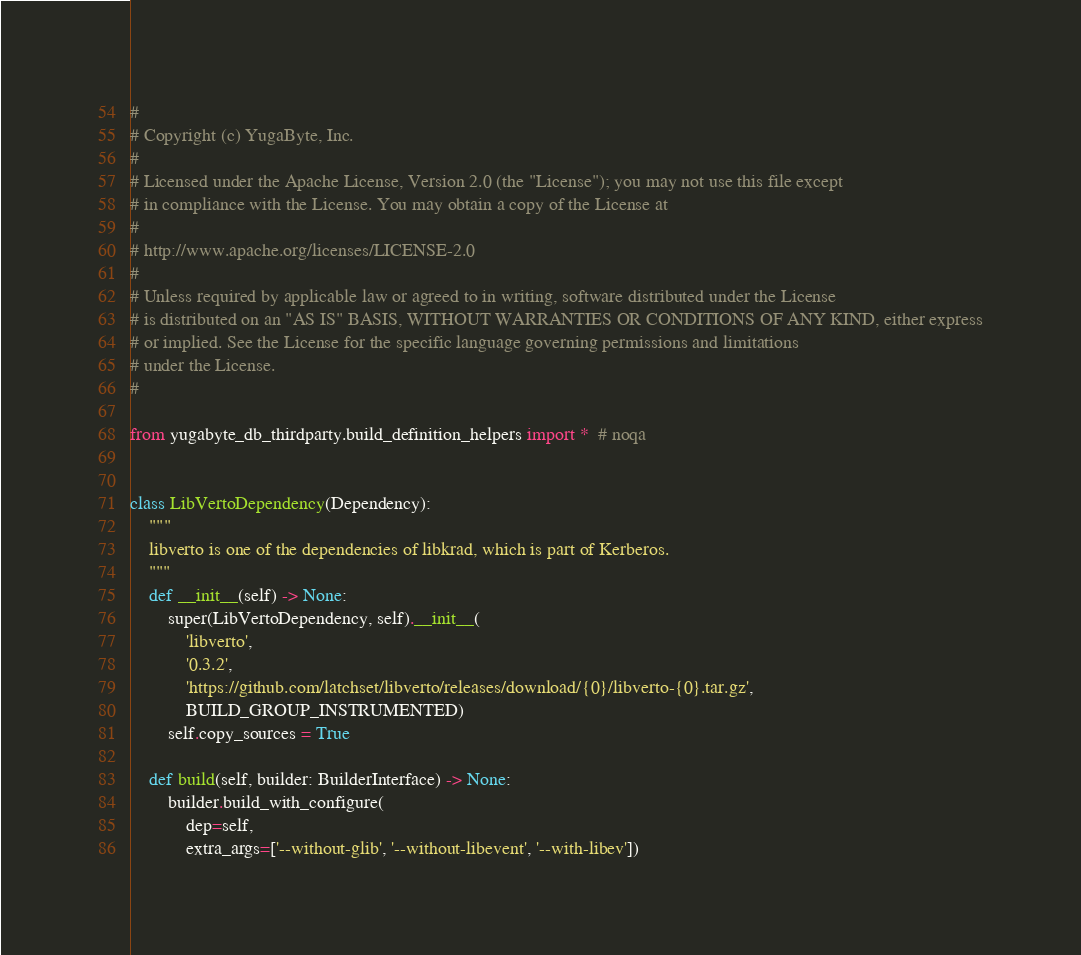<code> <loc_0><loc_0><loc_500><loc_500><_Python_>#
# Copyright (c) YugaByte, Inc.
#
# Licensed under the Apache License, Version 2.0 (the "License"); you may not use this file except
# in compliance with the License. You may obtain a copy of the License at
#
# http://www.apache.org/licenses/LICENSE-2.0
#
# Unless required by applicable law or agreed to in writing, software distributed under the License
# is distributed on an "AS IS" BASIS, WITHOUT WARRANTIES OR CONDITIONS OF ANY KIND, either express
# or implied. See the License for the specific language governing permissions and limitations
# under the License.
#

from yugabyte_db_thirdparty.build_definition_helpers import *  # noqa


class LibVertoDependency(Dependency):
    """
    libverto is one of the dependencies of libkrad, which is part of Kerberos.
    """
    def __init__(self) -> None:
        super(LibVertoDependency, self).__init__(
            'libverto',
            '0.3.2',
            'https://github.com/latchset/libverto/releases/download/{0}/libverto-{0}.tar.gz',
            BUILD_GROUP_INSTRUMENTED)
        self.copy_sources = True

    def build(self, builder: BuilderInterface) -> None:
        builder.build_with_configure(
            dep=self,
            extra_args=['--without-glib', '--without-libevent', '--with-libev'])
</code> 